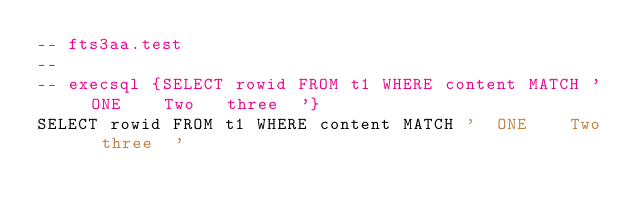Convert code to text. <code><loc_0><loc_0><loc_500><loc_500><_SQL_>-- fts3aa.test
-- 
-- execsql {SELECT rowid FROM t1 WHERE content MATCH '  ONE    Two   three  '}
SELECT rowid FROM t1 WHERE content MATCH '  ONE    Two   three  '</code> 